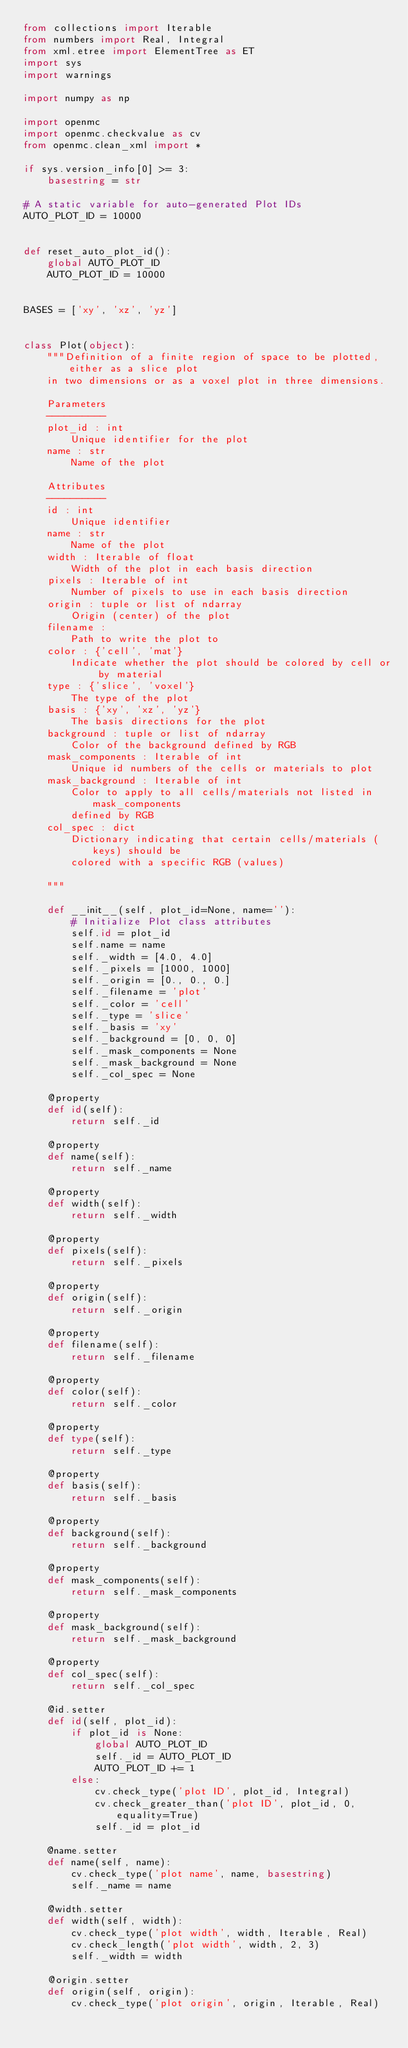Convert code to text. <code><loc_0><loc_0><loc_500><loc_500><_Python_>from collections import Iterable
from numbers import Real, Integral
from xml.etree import ElementTree as ET
import sys
import warnings

import numpy as np

import openmc
import openmc.checkvalue as cv
from openmc.clean_xml import *

if sys.version_info[0] >= 3:
    basestring = str

# A static variable for auto-generated Plot IDs
AUTO_PLOT_ID = 10000


def reset_auto_plot_id():
    global AUTO_PLOT_ID
    AUTO_PLOT_ID = 10000


BASES = ['xy', 'xz', 'yz']


class Plot(object):
    """Definition of a finite region of space to be plotted, either as a slice plot
    in two dimensions or as a voxel plot in three dimensions.

    Parameters
    ----------
    plot_id : int
        Unique identifier for the plot
    name : str
        Name of the plot

    Attributes
    ----------
    id : int
        Unique identifier
    name : str
        Name of the plot
    width : Iterable of float
        Width of the plot in each basis direction
    pixels : Iterable of int
        Number of pixels to use in each basis direction
    origin : tuple or list of ndarray
        Origin (center) of the plot
    filename :
        Path to write the plot to
    color : {'cell', 'mat'}
        Indicate whether the plot should be colored by cell or by material
    type : {'slice', 'voxel'}
        The type of the plot
    basis : {'xy', 'xz', 'yz'}
        The basis directions for the plot
    background : tuple or list of ndarray
        Color of the background defined by RGB
    mask_components : Iterable of int
        Unique id numbers of the cells or materials to plot
    mask_background : Iterable of int
        Color to apply to all cells/materials not listed in mask_components
        defined by RGB
    col_spec : dict
        Dictionary indicating that certain cells/materials (keys) should be
        colored with a specific RGB (values)

    """

    def __init__(self, plot_id=None, name=''):
        # Initialize Plot class attributes
        self.id = plot_id
        self.name = name
        self._width = [4.0, 4.0]
        self._pixels = [1000, 1000]
        self._origin = [0., 0., 0.]
        self._filename = 'plot'
        self._color = 'cell'
        self._type = 'slice'
        self._basis = 'xy'
        self._background = [0, 0, 0]
        self._mask_components = None
        self._mask_background = None
        self._col_spec = None

    @property
    def id(self):
        return self._id

    @property
    def name(self):
        return self._name

    @property
    def width(self):
        return self._width

    @property
    def pixels(self):
        return self._pixels

    @property
    def origin(self):
        return self._origin

    @property
    def filename(self):
        return self._filename

    @property
    def color(self):
        return self._color

    @property
    def type(self):
        return self._type

    @property
    def basis(self):
        return self._basis

    @property
    def background(self):
        return self._background

    @property
    def mask_components(self):
        return self._mask_components

    @property
    def mask_background(self):
        return self._mask_background

    @property
    def col_spec(self):
        return self._col_spec

    @id.setter
    def id(self, plot_id):
        if plot_id is None:
            global AUTO_PLOT_ID
            self._id = AUTO_PLOT_ID
            AUTO_PLOT_ID += 1
        else:
            cv.check_type('plot ID', plot_id, Integral)
            cv.check_greater_than('plot ID', plot_id, 0, equality=True)
            self._id = plot_id

    @name.setter
    def name(self, name):
        cv.check_type('plot name', name, basestring)
        self._name = name

    @width.setter
    def width(self, width):
        cv.check_type('plot width', width, Iterable, Real)
        cv.check_length('plot width', width, 2, 3)
        self._width = width

    @origin.setter
    def origin(self, origin):
        cv.check_type('plot origin', origin, Iterable, Real)</code> 